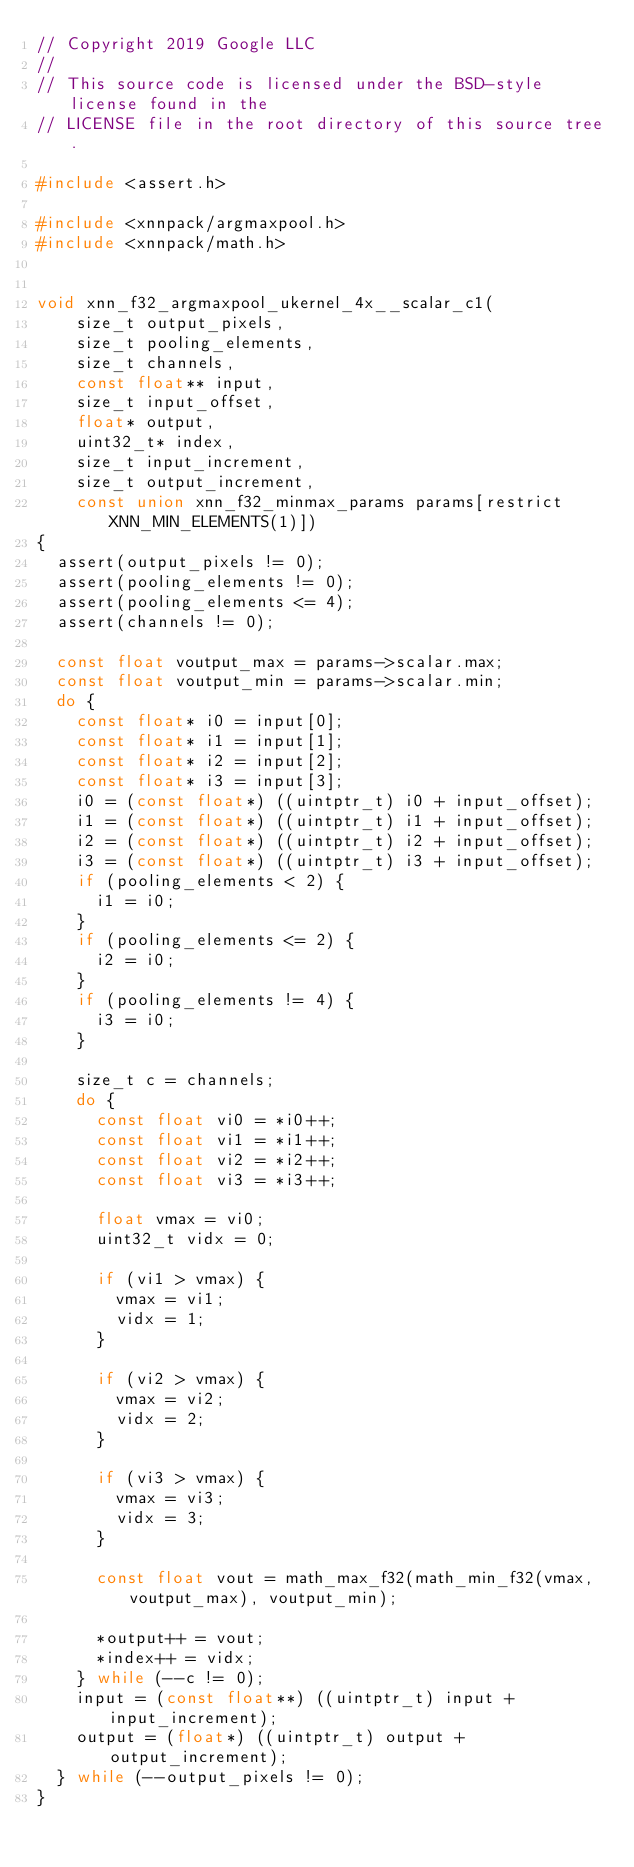<code> <loc_0><loc_0><loc_500><loc_500><_C_>// Copyright 2019 Google LLC
//
// This source code is licensed under the BSD-style license found in the
// LICENSE file in the root directory of this source tree.

#include <assert.h>

#include <xnnpack/argmaxpool.h>
#include <xnnpack/math.h>


void xnn_f32_argmaxpool_ukernel_4x__scalar_c1(
    size_t output_pixels,
    size_t pooling_elements,
    size_t channels,
    const float** input,
    size_t input_offset,
    float* output,
    uint32_t* index,
    size_t input_increment,
    size_t output_increment,
    const union xnn_f32_minmax_params params[restrict XNN_MIN_ELEMENTS(1)])
{
  assert(output_pixels != 0);
  assert(pooling_elements != 0);
  assert(pooling_elements <= 4);
  assert(channels != 0);

  const float voutput_max = params->scalar.max;
  const float voutput_min = params->scalar.min;
  do {
    const float* i0 = input[0];
    const float* i1 = input[1];
    const float* i2 = input[2];
    const float* i3 = input[3];
    i0 = (const float*) ((uintptr_t) i0 + input_offset);
    i1 = (const float*) ((uintptr_t) i1 + input_offset);
    i2 = (const float*) ((uintptr_t) i2 + input_offset);
    i3 = (const float*) ((uintptr_t) i3 + input_offset);
    if (pooling_elements < 2) {
      i1 = i0;
    }
    if (pooling_elements <= 2) {
      i2 = i0;
    }
    if (pooling_elements != 4) {
      i3 = i0;
    }

    size_t c = channels;
    do {
      const float vi0 = *i0++;
      const float vi1 = *i1++;
      const float vi2 = *i2++;
      const float vi3 = *i3++;

      float vmax = vi0;
      uint32_t vidx = 0;

      if (vi1 > vmax) {
        vmax = vi1;
        vidx = 1;
      }

      if (vi2 > vmax) {
        vmax = vi2;
        vidx = 2;
      }

      if (vi3 > vmax) {
        vmax = vi3;
        vidx = 3;
      }

      const float vout = math_max_f32(math_min_f32(vmax, voutput_max), voutput_min);

      *output++ = vout;
      *index++ = vidx;
    } while (--c != 0);
    input = (const float**) ((uintptr_t) input + input_increment);
    output = (float*) ((uintptr_t) output + output_increment);
  } while (--output_pixels != 0);
}
</code> 